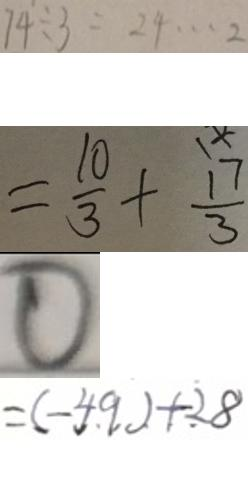<formula> <loc_0><loc_0><loc_500><loc_500>7 4 \div 3 = 2 4 \cdots 2 
 = \frac { 1 0 } { 3 } + \frac { 1 7 } { 3 } 
 0 
 = ( - 4 9 ) + 2 8</formula> 